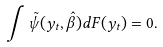Convert formula to latex. <formula><loc_0><loc_0><loc_500><loc_500>\int \tilde { \psi } ( y _ { t } , \hat { \beta } ) d F ( y _ { t } ) = 0 .</formula> 